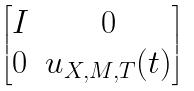Convert formula to latex. <formula><loc_0><loc_0><loc_500><loc_500>\begin{bmatrix} I & 0 \\ 0 & u _ { X , M , T } ( t ) \end{bmatrix}</formula> 